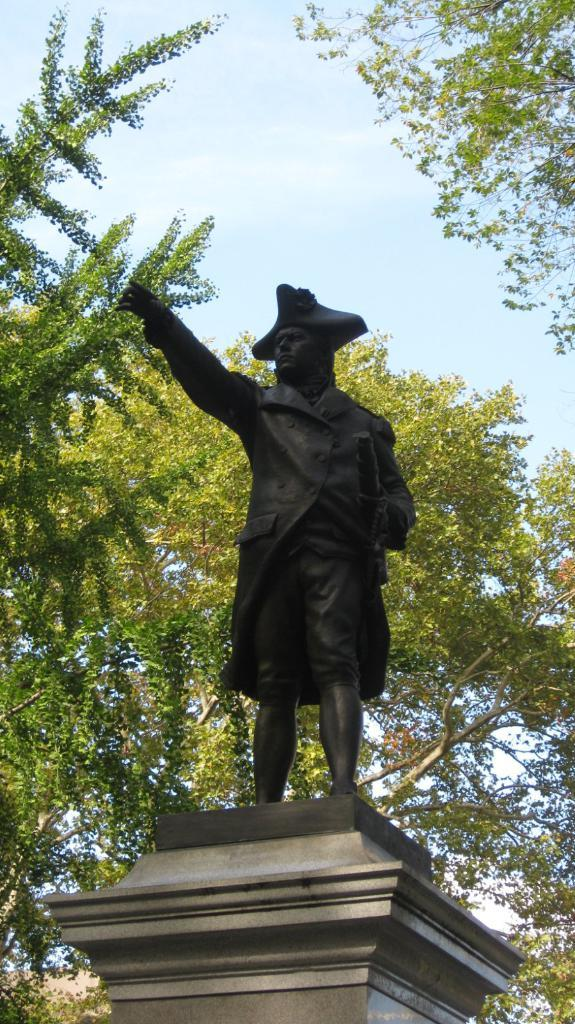What is the main subject of the image? There is a human statue in the image. Where is the human statue located? The human statue is on a pillar. What can be seen in the background of the image? There are trees and the sky visible in the background of the image. Can you tell me how many faucets are visible in the image? There are no faucets present in the image. What type of fight is taking place in the image? There is no fight depicted in the image; it features a human statue on a pillar. 